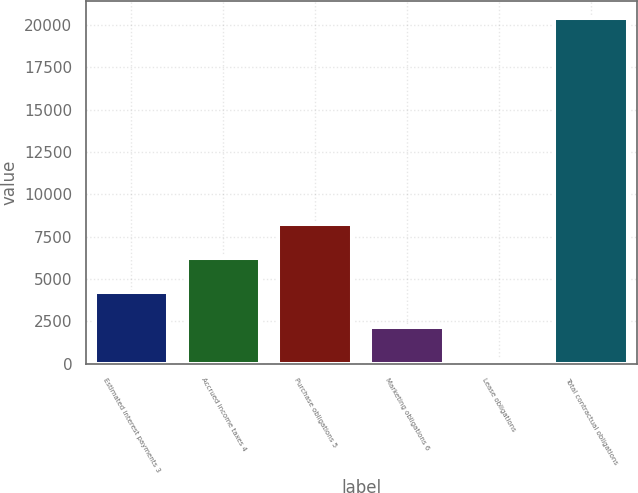<chart> <loc_0><loc_0><loc_500><loc_500><bar_chart><fcel>Estimated interest payments 3<fcel>Accrued income taxes 4<fcel>Purchase obligations 5<fcel>Marketing obligations 6<fcel>Lease obligations<fcel>Total contractual obligations<nl><fcel>4206.4<fcel>6229.1<fcel>8251.8<fcel>2183.7<fcel>161<fcel>20388<nl></chart> 